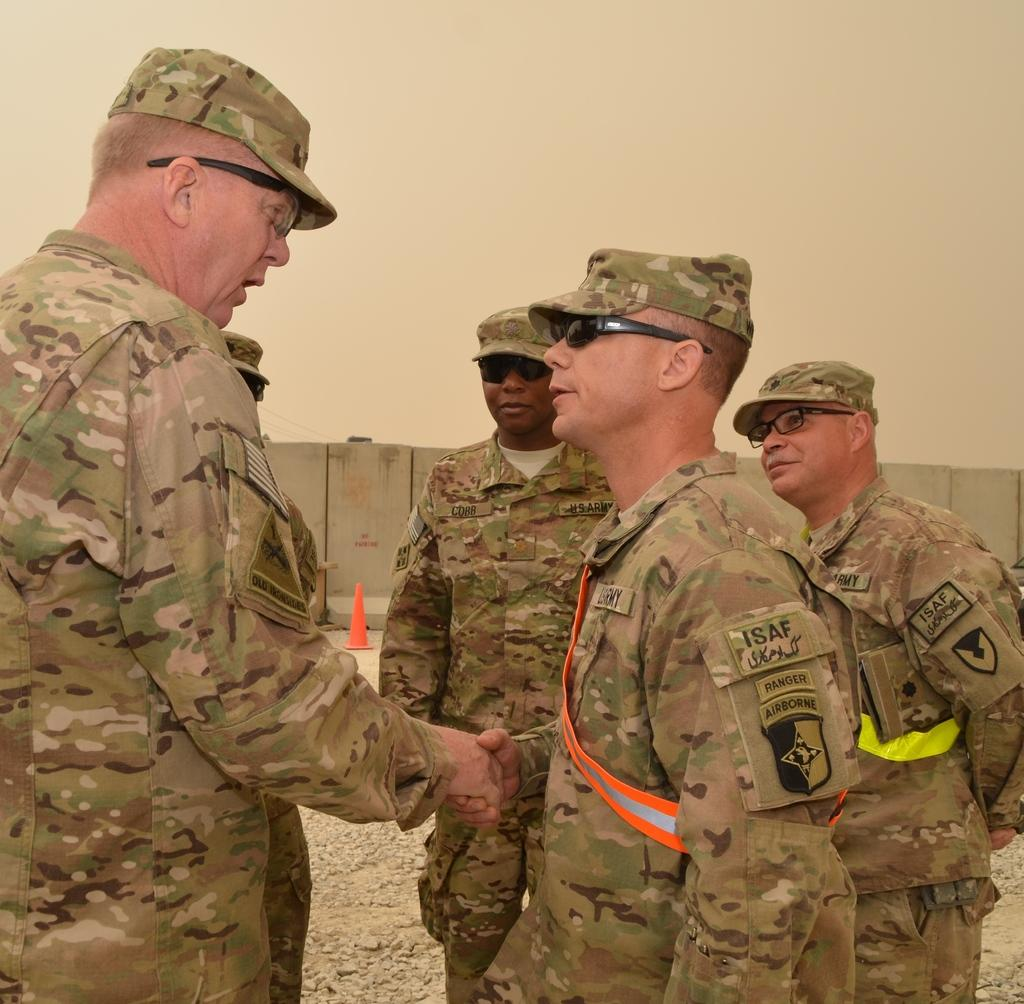What type of people are in the image? There are army persons in the image. What accessories are the army persons wearing? The army persons are wearing caps, shirts, and goggles. What can be seen in the background of the image? There is a concrete wall in the background of the image. What other object is present near the wall? There is a traffic cone beside the wall in the image. What type of chin is visible on the army person in the image? There is no chin visible on the army person in the image; the focus is on their clothing and accessories. 